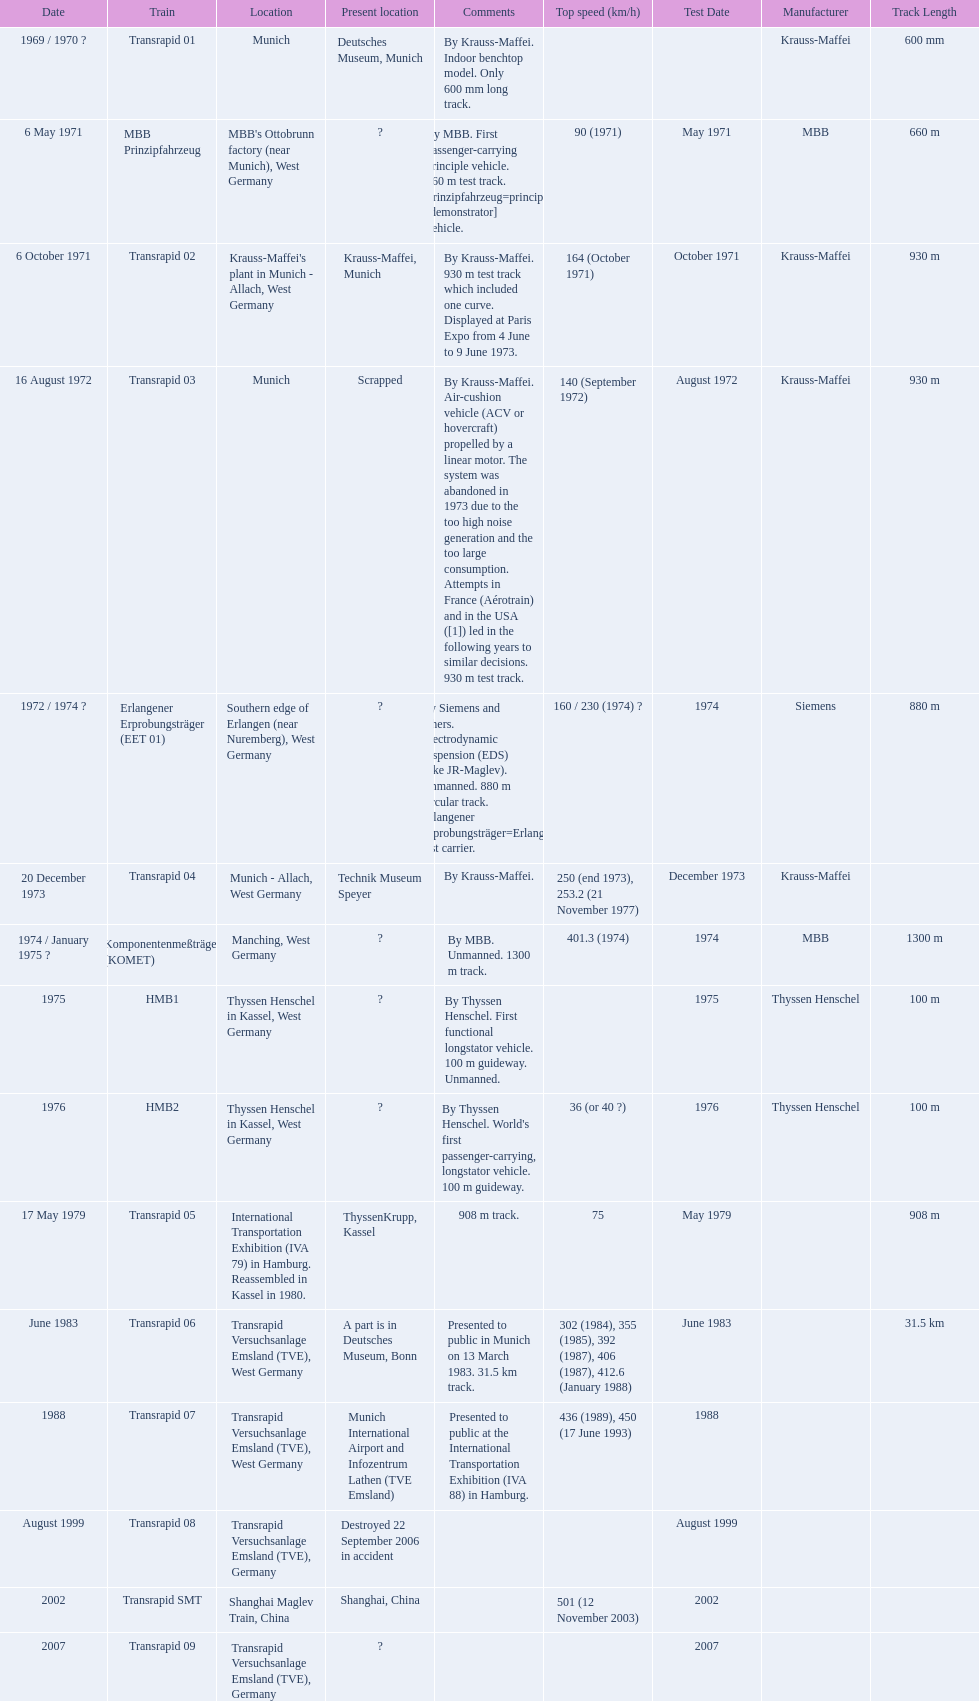Which trains exceeded a top speed of 400+? Komponentenmeßträger (KOMET), Transrapid 07, Transrapid SMT. How about 500+? Transrapid SMT. 